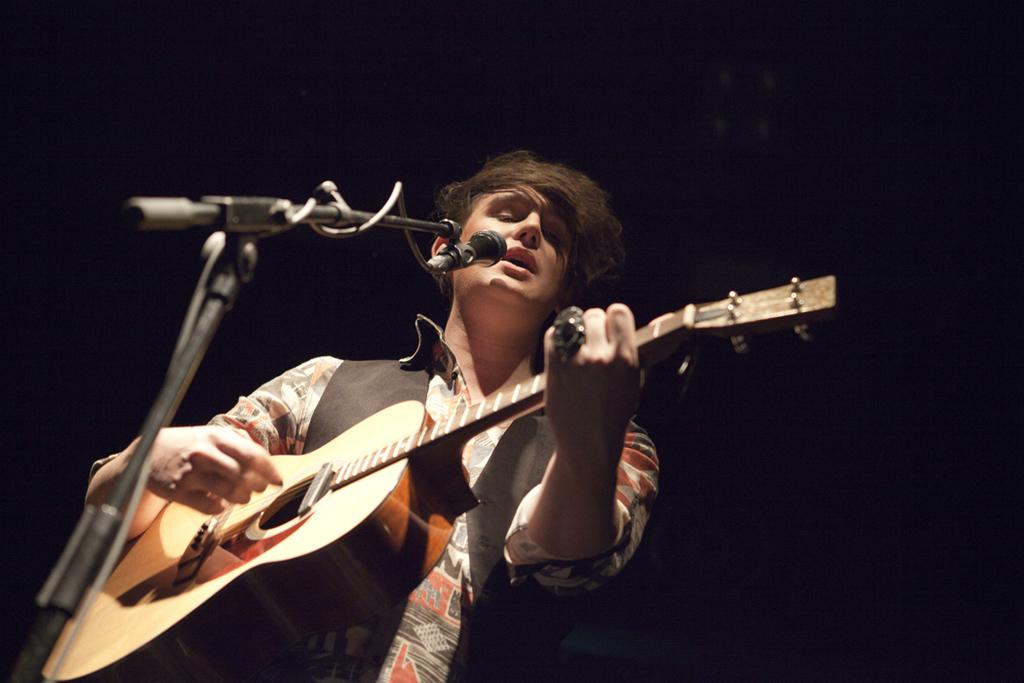Who or what is the main subject in the image? There is a person in the image. What is the person holding in the image? The person is holding a guitar. What object is in front of the person? There is a microphone in front of the person. What type of crown is the person wearing in the image? There is no crown present in the image; the person is holding a guitar and standing in front of a microphone. 